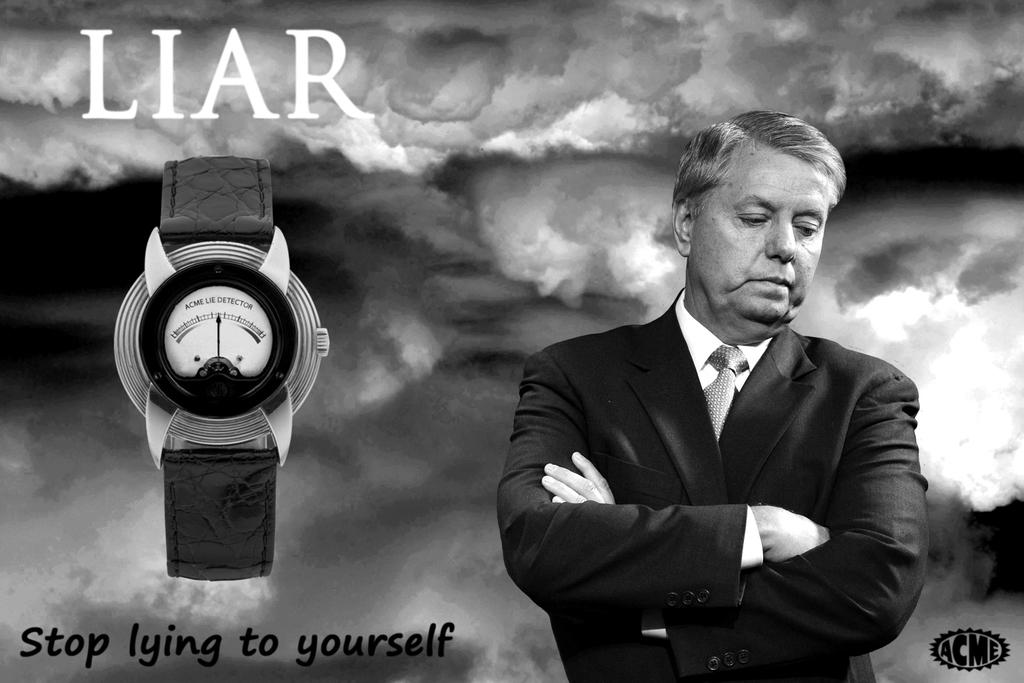<image>
Write a terse but informative summary of the picture. A watch ad says LIAR at the top and shows a man with his arms crossed. 